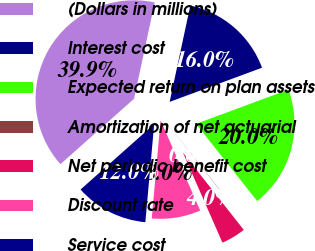<chart> <loc_0><loc_0><loc_500><loc_500><pie_chart><fcel>(Dollars in millions)<fcel>Interest cost<fcel>Expected return on plan assets<fcel>Amortization of net actuarial<fcel>Net periodic benefit cost<fcel>Discount rate<fcel>Service cost<nl><fcel>39.93%<fcel>16.0%<fcel>19.98%<fcel>0.04%<fcel>4.03%<fcel>8.02%<fcel>12.01%<nl></chart> 